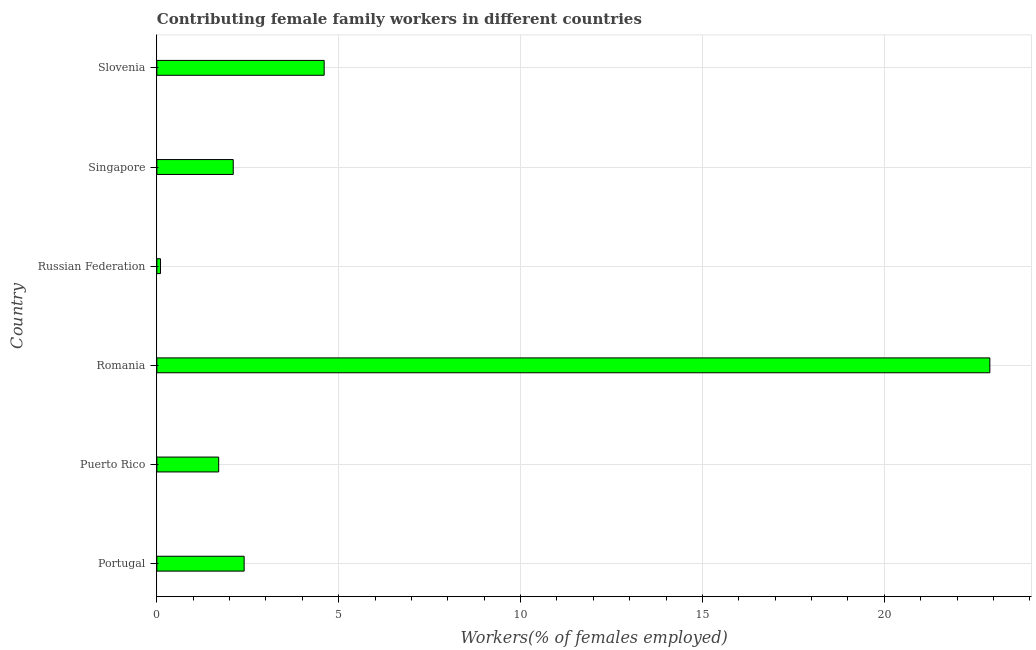Does the graph contain any zero values?
Provide a short and direct response. No. What is the title of the graph?
Your response must be concise. Contributing female family workers in different countries. What is the label or title of the X-axis?
Offer a terse response. Workers(% of females employed). What is the contributing female family workers in Romania?
Ensure brevity in your answer.  22.9. Across all countries, what is the maximum contributing female family workers?
Give a very brief answer. 22.9. Across all countries, what is the minimum contributing female family workers?
Keep it short and to the point. 0.1. In which country was the contributing female family workers maximum?
Provide a short and direct response. Romania. In which country was the contributing female family workers minimum?
Ensure brevity in your answer.  Russian Federation. What is the sum of the contributing female family workers?
Your response must be concise. 33.8. What is the difference between the contributing female family workers in Russian Federation and Singapore?
Ensure brevity in your answer.  -2. What is the average contributing female family workers per country?
Your answer should be very brief. 5.63. What is the median contributing female family workers?
Offer a very short reply. 2.25. What is the ratio of the contributing female family workers in Romania to that in Russian Federation?
Provide a short and direct response. 229. Is the difference between the contributing female family workers in Romania and Slovenia greater than the difference between any two countries?
Offer a terse response. No. What is the difference between the highest and the second highest contributing female family workers?
Ensure brevity in your answer.  18.3. What is the difference between the highest and the lowest contributing female family workers?
Give a very brief answer. 22.8. Are all the bars in the graph horizontal?
Make the answer very short. Yes. What is the difference between two consecutive major ticks on the X-axis?
Provide a succinct answer. 5. What is the Workers(% of females employed) in Portugal?
Make the answer very short. 2.4. What is the Workers(% of females employed) of Puerto Rico?
Your response must be concise. 1.7. What is the Workers(% of females employed) of Romania?
Offer a terse response. 22.9. What is the Workers(% of females employed) of Russian Federation?
Provide a short and direct response. 0.1. What is the Workers(% of females employed) in Singapore?
Make the answer very short. 2.1. What is the Workers(% of females employed) in Slovenia?
Your response must be concise. 4.6. What is the difference between the Workers(% of females employed) in Portugal and Romania?
Offer a terse response. -20.5. What is the difference between the Workers(% of females employed) in Portugal and Russian Federation?
Your response must be concise. 2.3. What is the difference between the Workers(% of females employed) in Portugal and Singapore?
Keep it short and to the point. 0.3. What is the difference between the Workers(% of females employed) in Puerto Rico and Romania?
Your answer should be very brief. -21.2. What is the difference between the Workers(% of females employed) in Puerto Rico and Russian Federation?
Give a very brief answer. 1.6. What is the difference between the Workers(% of females employed) in Puerto Rico and Singapore?
Offer a very short reply. -0.4. What is the difference between the Workers(% of females employed) in Puerto Rico and Slovenia?
Make the answer very short. -2.9. What is the difference between the Workers(% of females employed) in Romania and Russian Federation?
Offer a terse response. 22.8. What is the difference between the Workers(% of females employed) in Romania and Singapore?
Ensure brevity in your answer.  20.8. What is the difference between the Workers(% of females employed) in Russian Federation and Singapore?
Offer a very short reply. -2. What is the difference between the Workers(% of females employed) in Russian Federation and Slovenia?
Make the answer very short. -4.5. What is the difference between the Workers(% of females employed) in Singapore and Slovenia?
Offer a very short reply. -2.5. What is the ratio of the Workers(% of females employed) in Portugal to that in Puerto Rico?
Offer a terse response. 1.41. What is the ratio of the Workers(% of females employed) in Portugal to that in Romania?
Ensure brevity in your answer.  0.1. What is the ratio of the Workers(% of females employed) in Portugal to that in Singapore?
Offer a terse response. 1.14. What is the ratio of the Workers(% of females employed) in Portugal to that in Slovenia?
Provide a short and direct response. 0.52. What is the ratio of the Workers(% of females employed) in Puerto Rico to that in Romania?
Provide a short and direct response. 0.07. What is the ratio of the Workers(% of females employed) in Puerto Rico to that in Singapore?
Give a very brief answer. 0.81. What is the ratio of the Workers(% of females employed) in Puerto Rico to that in Slovenia?
Provide a short and direct response. 0.37. What is the ratio of the Workers(% of females employed) in Romania to that in Russian Federation?
Provide a succinct answer. 229. What is the ratio of the Workers(% of females employed) in Romania to that in Singapore?
Make the answer very short. 10.9. What is the ratio of the Workers(% of females employed) in Romania to that in Slovenia?
Offer a terse response. 4.98. What is the ratio of the Workers(% of females employed) in Russian Federation to that in Singapore?
Your answer should be compact. 0.05. What is the ratio of the Workers(% of females employed) in Russian Federation to that in Slovenia?
Your answer should be compact. 0.02. What is the ratio of the Workers(% of females employed) in Singapore to that in Slovenia?
Offer a terse response. 0.46. 